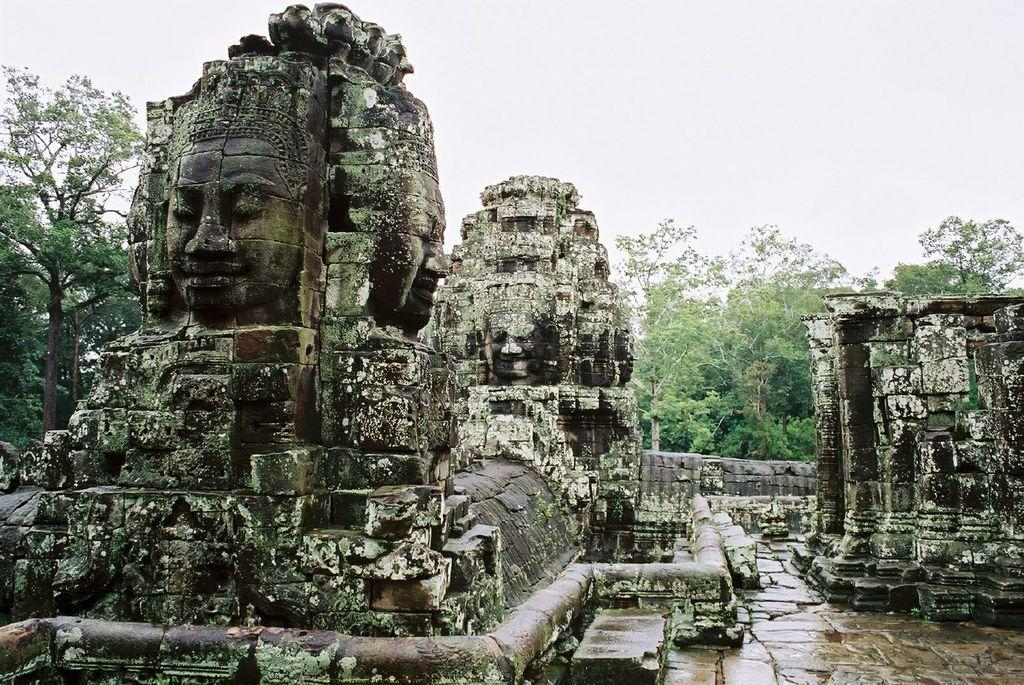What can be seen on the left side of the image? There is a sculpture and trees on the left side of the image. What is located on the right side of the image? There are stone pillars and trees on the right side of the image. What is visible at the top of the image? The sky is visible at the top of the image. Where is the wrench being used in the image? There is no wrench present in the image. What type of desk can be seen in the image? There is no desk present in the image. 